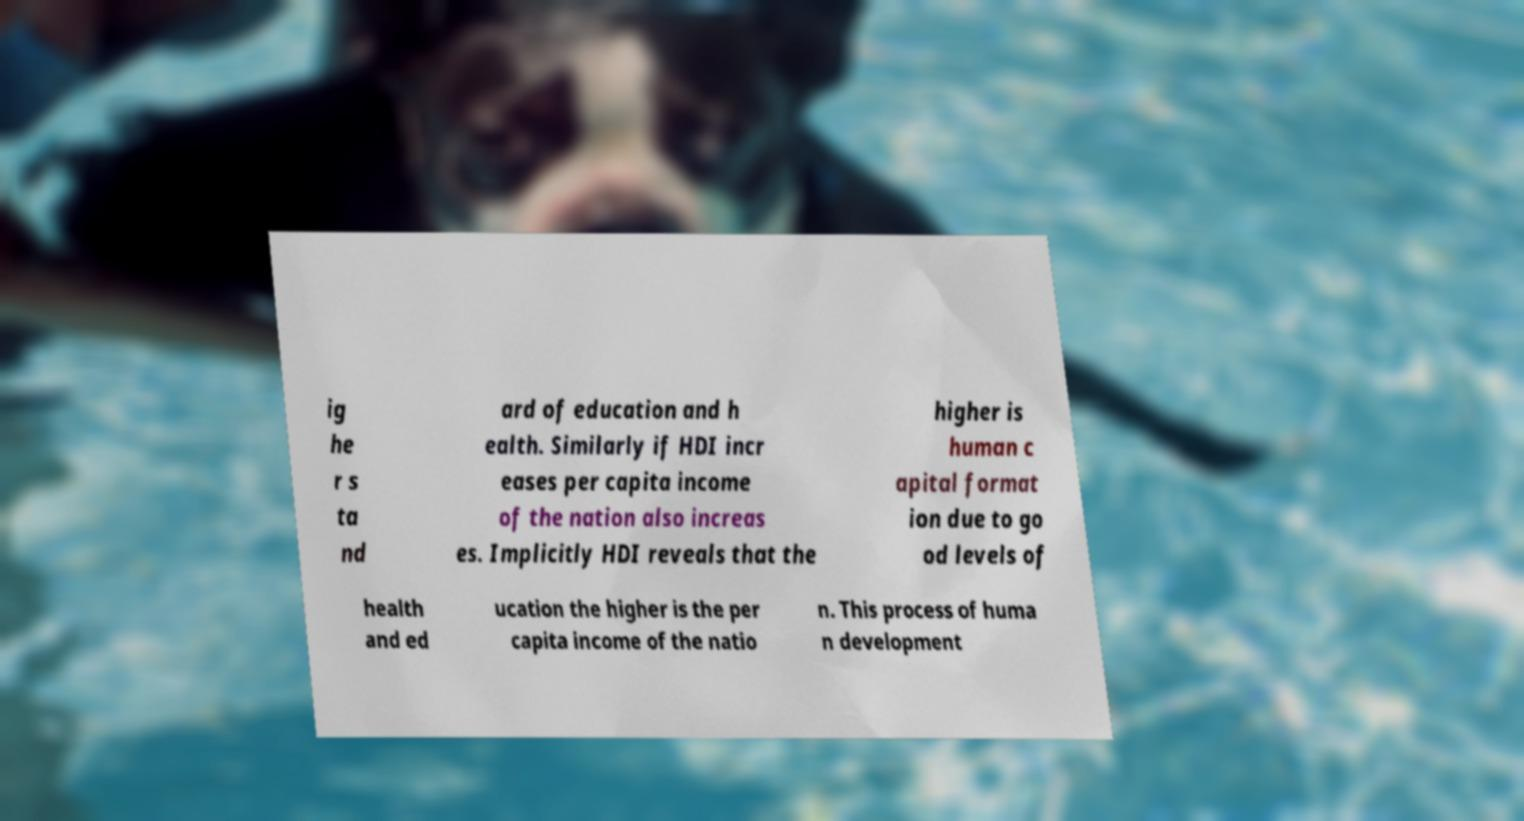There's text embedded in this image that I need extracted. Can you transcribe it verbatim? ig he r s ta nd ard of education and h ealth. Similarly if HDI incr eases per capita income of the nation also increas es. Implicitly HDI reveals that the higher is human c apital format ion due to go od levels of health and ed ucation the higher is the per capita income of the natio n. This process of huma n development 